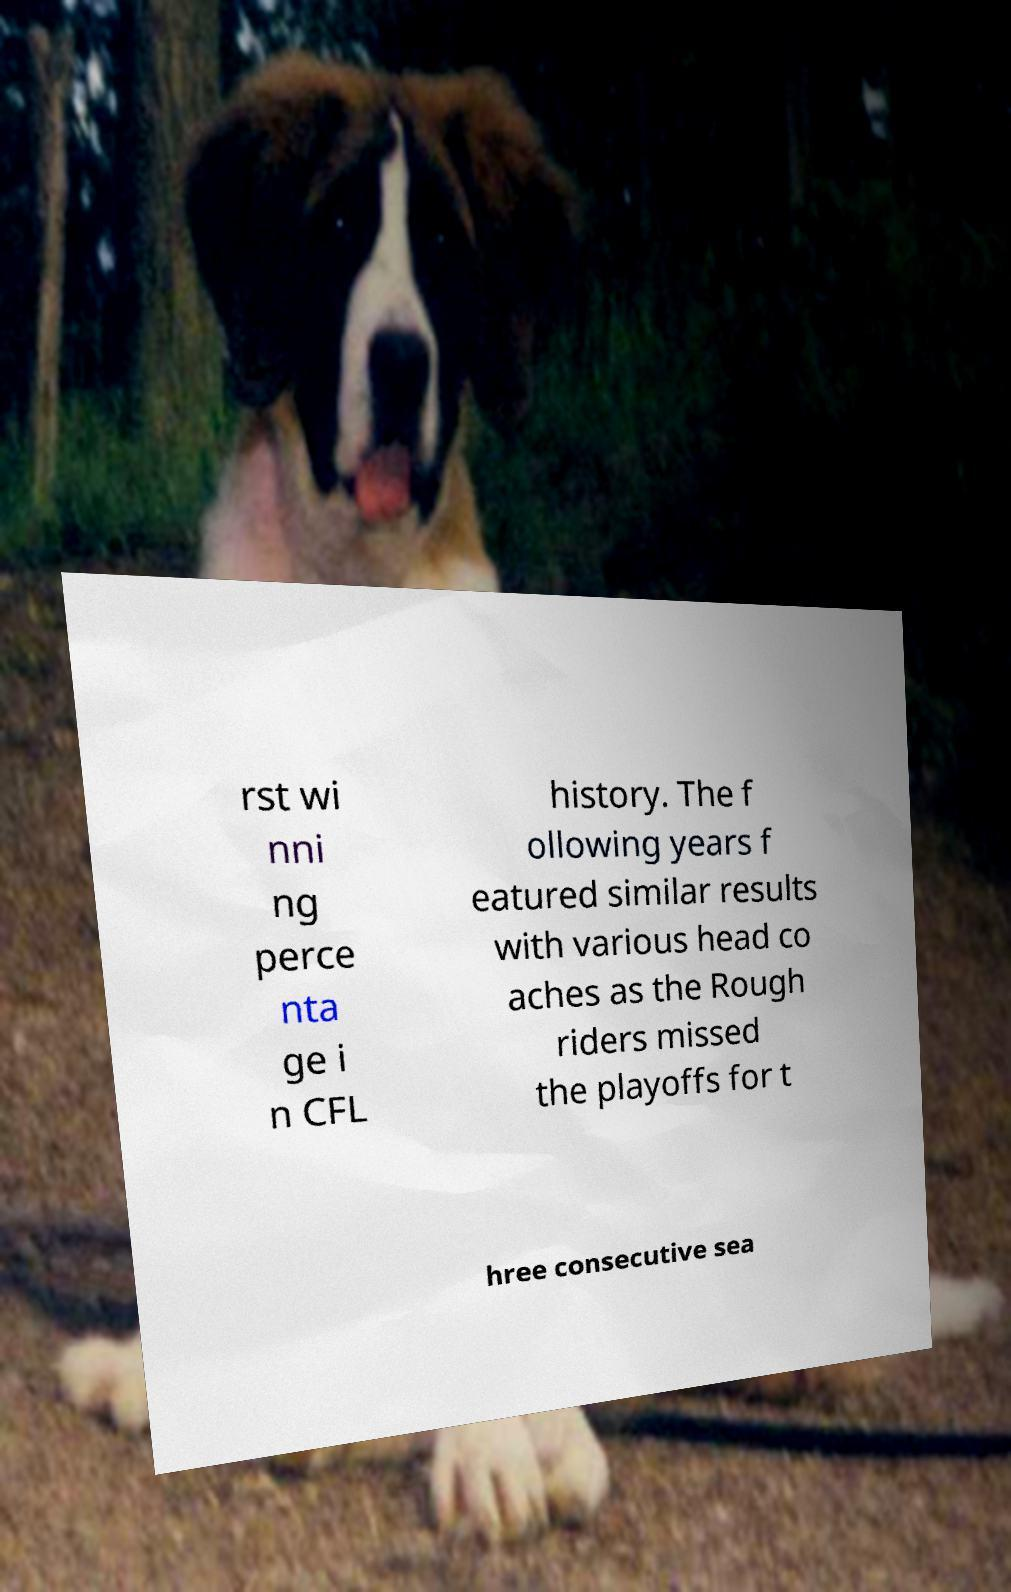Can you read and provide the text displayed in the image?This photo seems to have some interesting text. Can you extract and type it out for me? rst wi nni ng perce nta ge i n CFL history. The f ollowing years f eatured similar results with various head co aches as the Rough riders missed the playoffs for t hree consecutive sea 